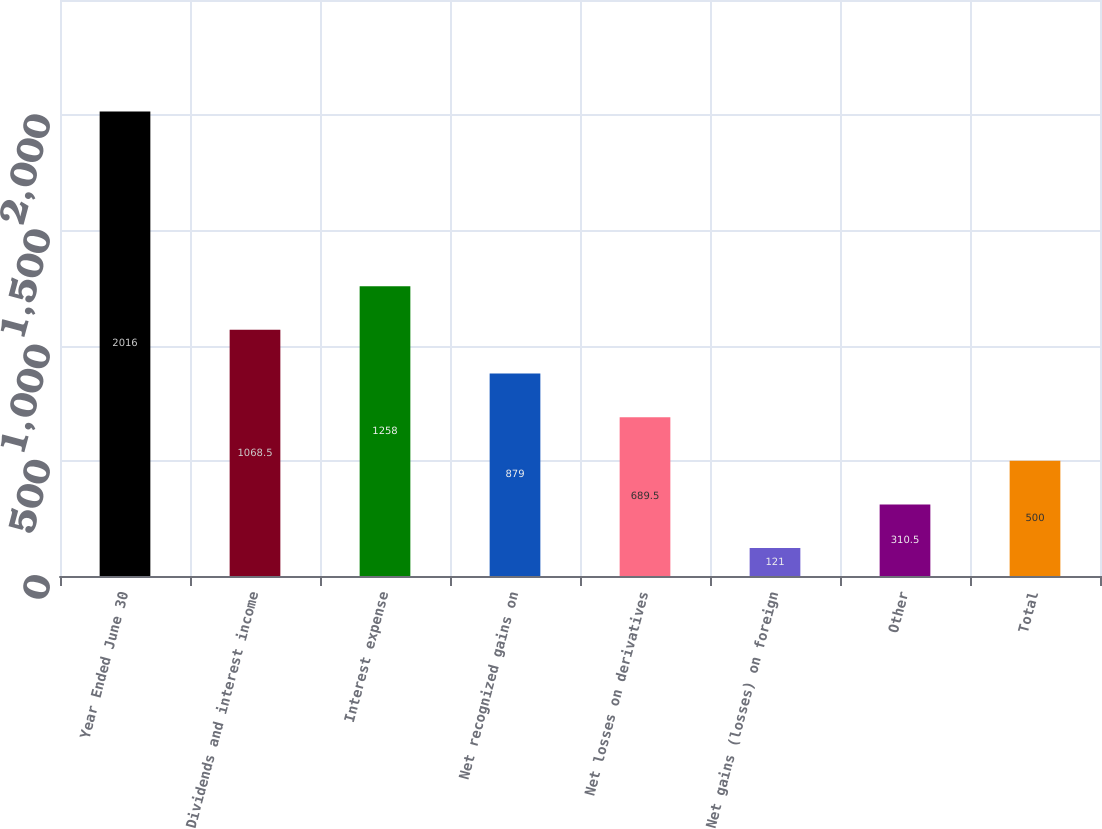<chart> <loc_0><loc_0><loc_500><loc_500><bar_chart><fcel>Year Ended June 30<fcel>Dividends and interest income<fcel>Interest expense<fcel>Net recognized gains on<fcel>Net losses on derivatives<fcel>Net gains (losses) on foreign<fcel>Other<fcel>Total<nl><fcel>2016<fcel>1068.5<fcel>1258<fcel>879<fcel>689.5<fcel>121<fcel>310.5<fcel>500<nl></chart> 